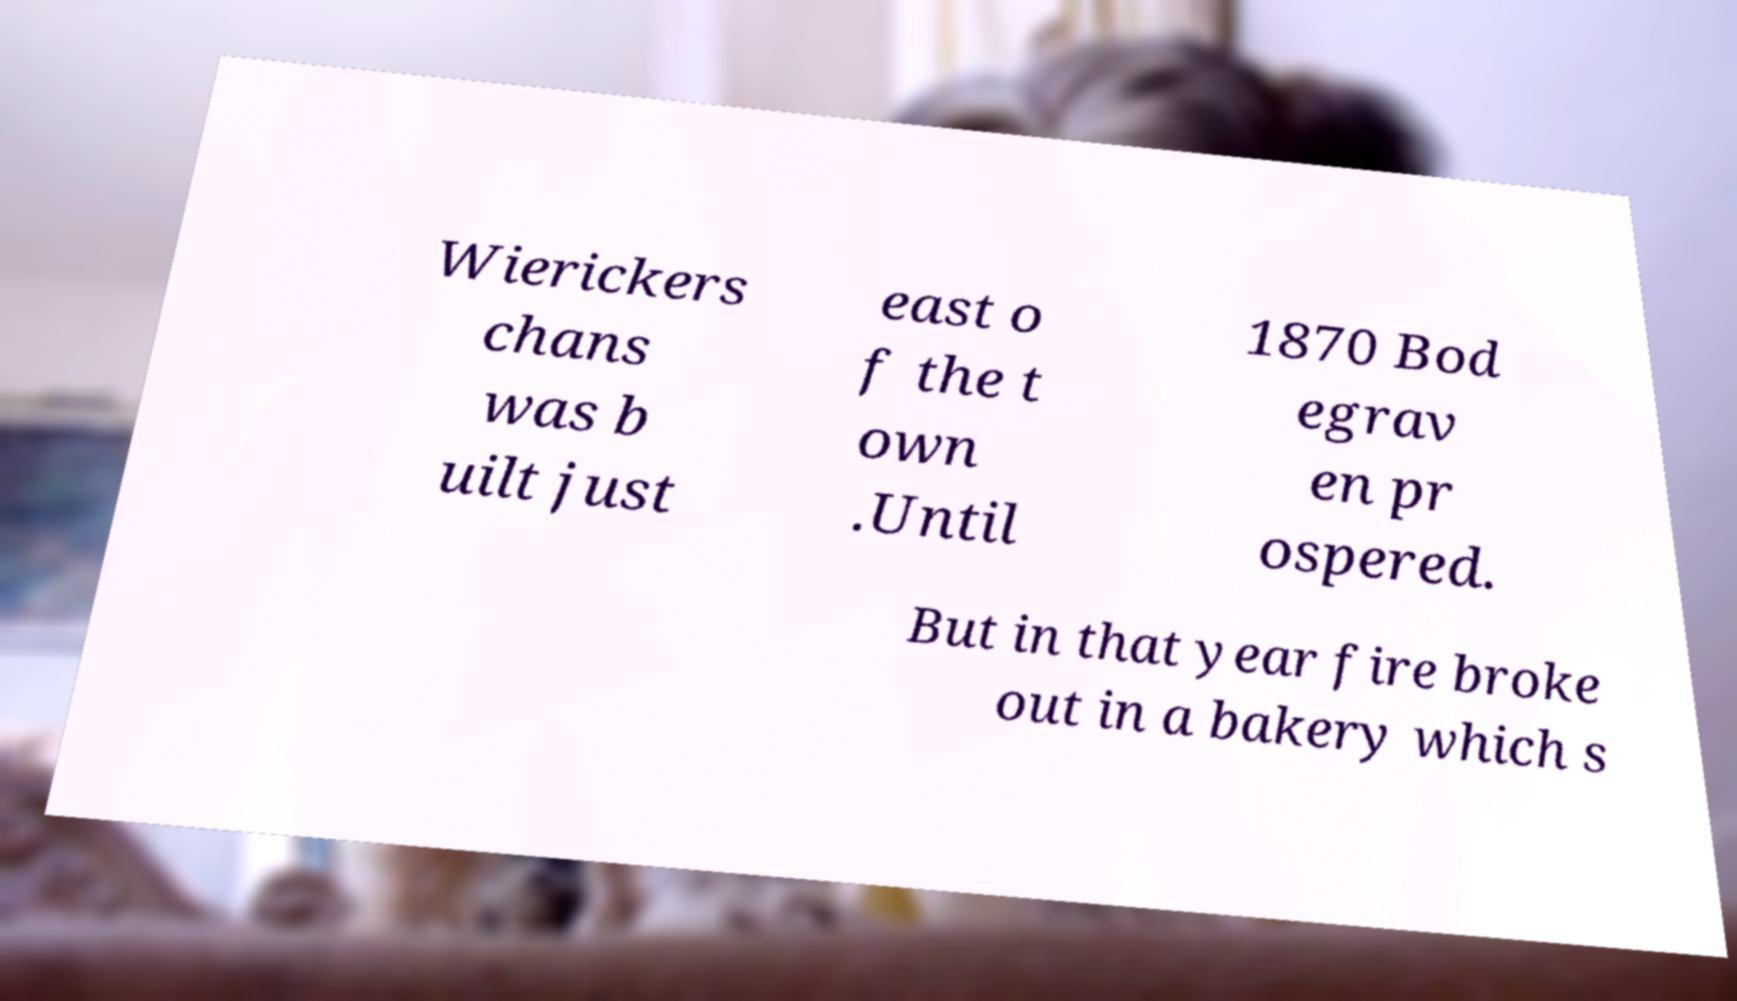Please identify and transcribe the text found in this image. Wierickers chans was b uilt just east o f the t own .Until 1870 Bod egrav en pr ospered. But in that year fire broke out in a bakery which s 